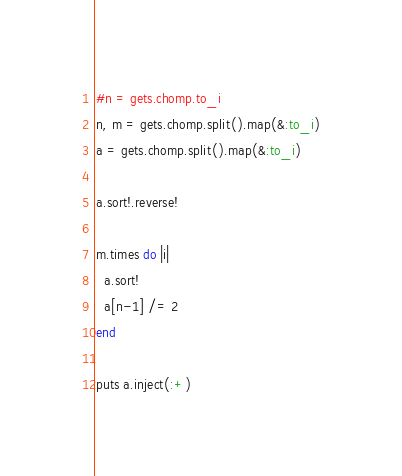Convert code to text. <code><loc_0><loc_0><loc_500><loc_500><_Ruby_>#n = gets.chomp.to_i
n, m = gets.chomp.split().map(&:to_i)
a = gets.chomp.split().map(&:to_i)

a.sort!.reverse!

m.times do |i|
  a.sort!
  a[n-1] /= 2
end

puts a.inject(:+)
</code> 